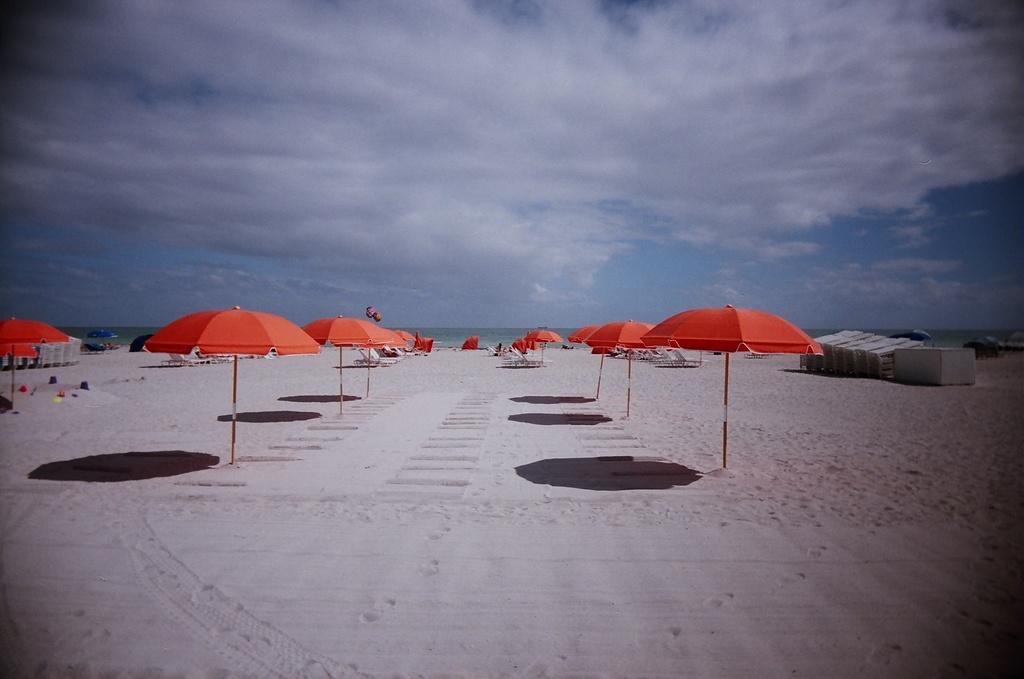What type of structures are present in the image? There are tents in the image. What color are the tents? The tents are red in color. Where are the tents located in the image? The tents are in the center of the image. What is the condition of the sky in the image? The sky is cloudy in the image. What type of plate is being used to hold the nuts in the image? There is no plate or nuts present in the image; it only features red tents and a cloudy sky. 